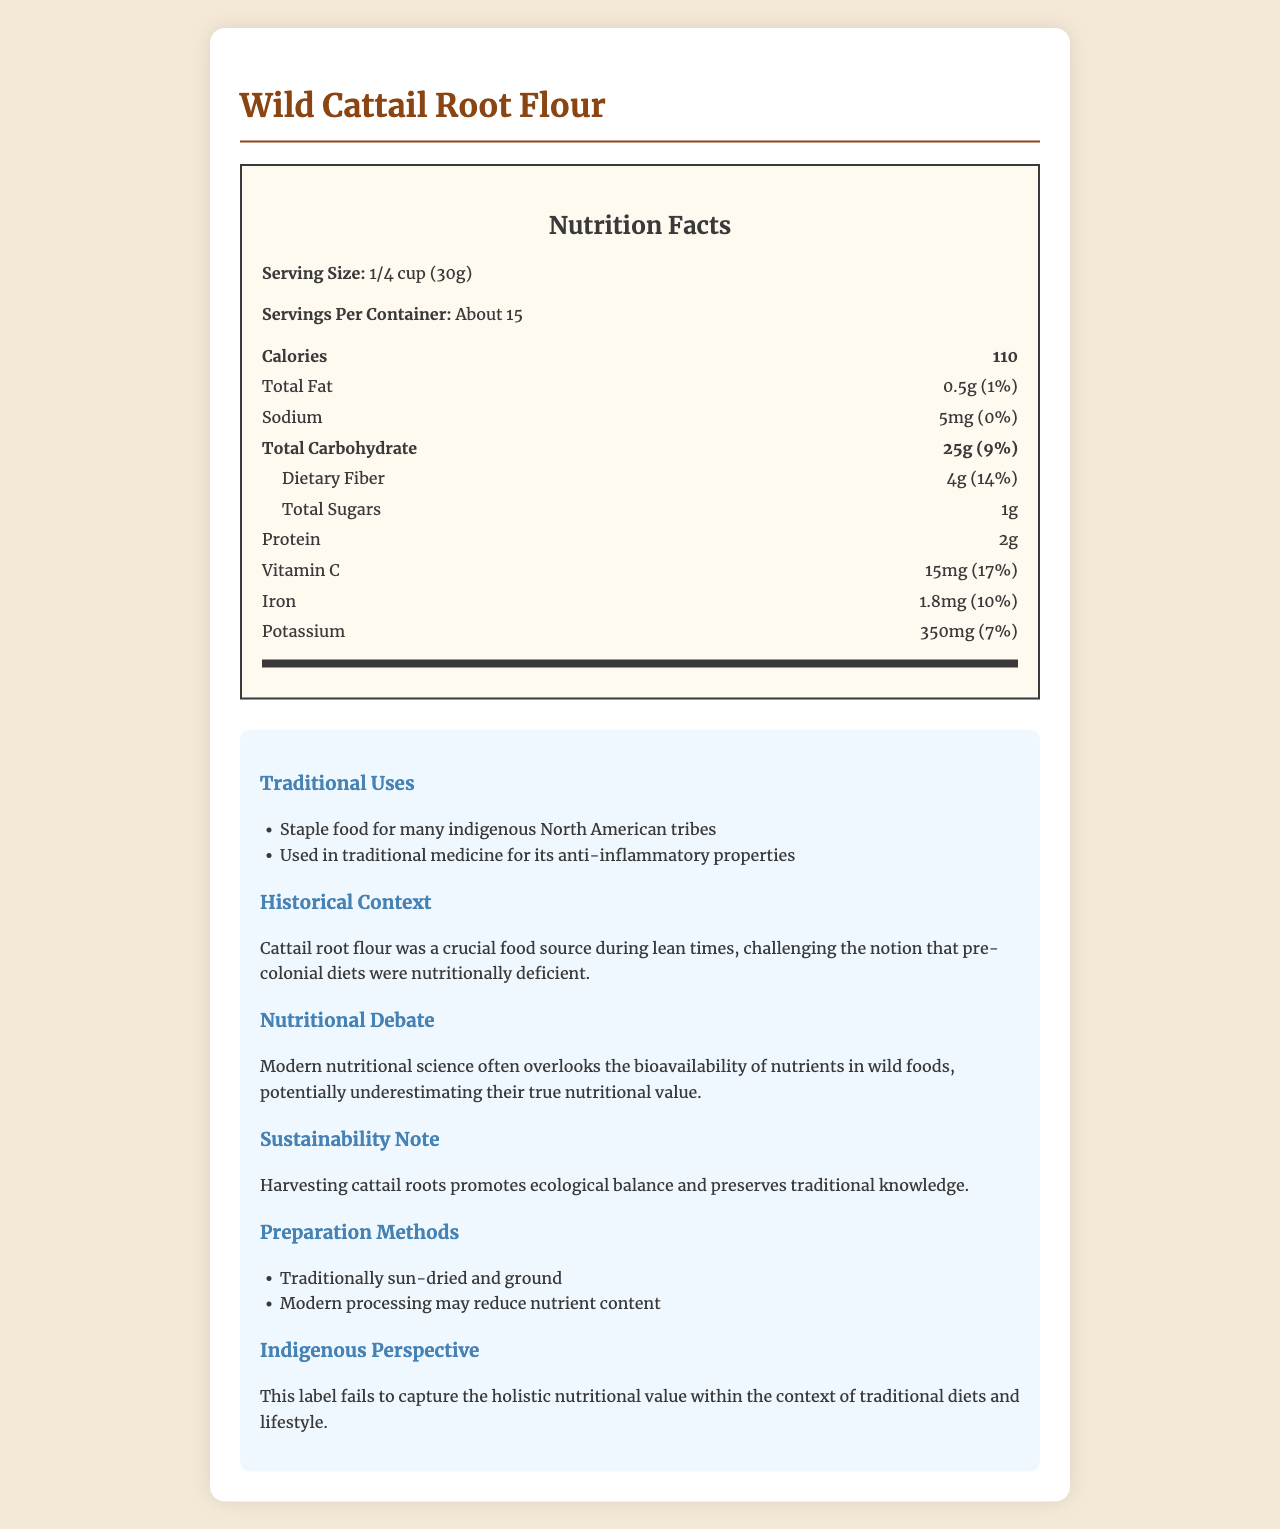what is the serving size? The serving size is clearly stated in the nutrition label as "1/4 cup (30g)".
Answer: 1/4 cup (30g) how many servings per container? The document states that there are about 15 servings per container.
Answer: About 15 how many grams of dietary fiber are in one serving? The nutrition label specifies that there are 4g of dietary fiber per serving.
Answer: 4g how many calories are in one serving? The nutrition label lists the calorie content as 110 per serving.
Answer: 110 how much vitamin C does a serving provide? The nutrition label indicates that one serving provides 15mg of vitamin C.
Answer: 15mg what traditional uses are mentioned for Wild Cattail Root Flour? The document lists the traditional uses of Wild Cattail Root Flour in the "Traditional Uses" section.
Answer: Staple food for many indigenous North American tribes, Used in traditional medicine for its anti-inflammatory properties which nutrient has the highest daily value percentage per serving? A. Vitamin C B. Iron C. Potassium The document states that vitamin C has a daily value of 17%.
Answer: A. Vitamin C how is Wild Cattail Root Flour traditionally prepared? A. Sun-dried and ground B. Roasted C. Boiled The "Preparation Methods" section lists "Traditionally sun-dried and ground".
Answer: A. Sun-dried and ground does Wild Cattail Root Flour contain any added sugars? The document specifies "Total Sugars: 1g", which implies natural sugars without specifying any added sugars.
Answer: No is the nutritional value of Wild Cattail Root Flour affected by modern processing? The document mentions in the "Preparation Methods" section that modern processing may reduce nutrient content.
Answer: Yes describe the main idea of the document. The document aims to present the nutritional value and traditional significance of Wild Cattail Root Flour while questioning modern perspectives on nutrition and sustainability.
Answer: The document provides detailed nutrition facts for Wild Cattail Root Flour, highlighting its traditional uses, preparation methods, historical context, and the debate on its nutritional value. It challenges modern nutritional assumptions by emphasizing the significance of indigenous knowledge and sustainable harvesting. what impact does foraging Wild Cattail Root have on the environment according to the document? The "Sustainability Note" section explains that harvesting cattail roots promotes ecological balance and preserves traditional knowledge.
Answer: Promotes ecological balance and preserves traditional knowledge does the document provide specific nutritional comparisons to modern food products? The document does not provide specific comparisons between Wild Cattail Root Flour and modern food products.
Answer: No how does the document suggest modern nutritional science views wild foods? The "Nutritional Debate" section mentions that modern nutritional science might underestimate the nutritional value of wild foods.
Answer: Often overlooks the bioavailability of nutrients in wild foods, potentially underestimating their true nutritional value what is the total fat content in one serving? The nutrition label lists the total fat content as 0.5g per serving.
Answer: 0.5g 